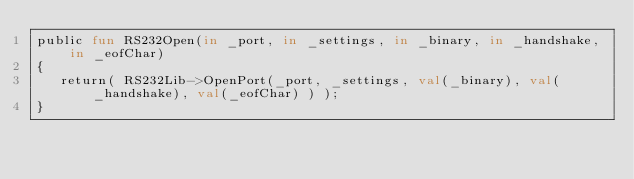<code> <loc_0><loc_0><loc_500><loc_500><_SML_>public fun RS232Open(in _port, in _settings, in _binary, in _handshake, in _eofChar)
{
   return( RS232Lib->OpenPort(_port, _settings, val(_binary), val(_handshake), val(_eofChar) ) );
}
</code> 